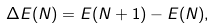<formula> <loc_0><loc_0><loc_500><loc_500>\Delta E ( N ) = E ( N + 1 ) - E ( N ) ,</formula> 